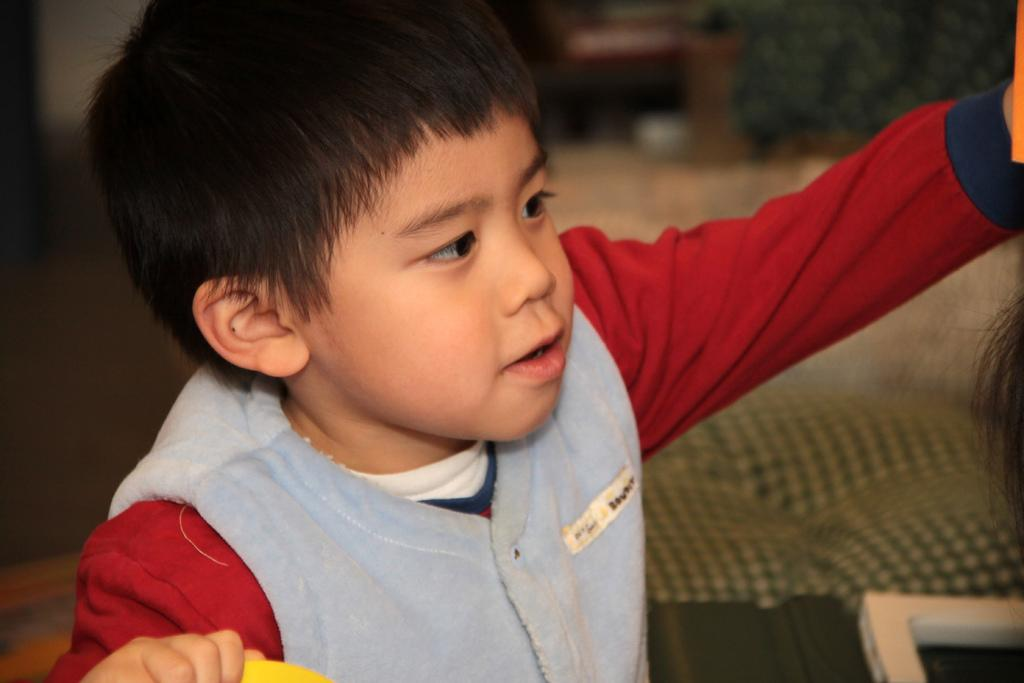Who is the main subject in the image? There is a boy in the image. What is the boy wearing? The boy is wearing a red dress and a blue jacket. What can be seen in the background of the image? There is a couch and other objects in the background of the image. What type of circle can be seen on the boy's head in the image? There is no circle present on the boy's head in the image. How many cakes are on the table next to the boy in the image? There is no table or cakes present in the image. 